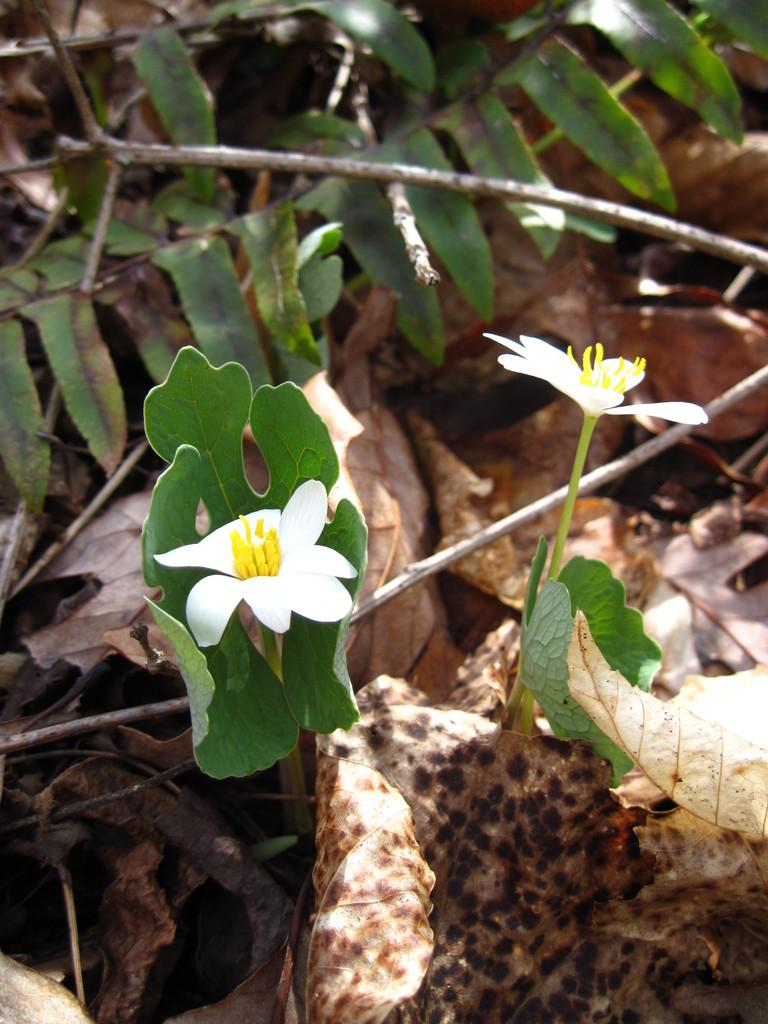What color are the leaves in the image? The leaves in the image are green. How many white color flowers are present in the image? There are two white color flowers in the image. What is the condition of some of the leaves in the image? There are dried leaves in the image. Where is the girl in the image? There is no girl present in the image; it features green leaves and white flowers. What type of land can be seen in the image? The image does not depict any land; it focuses on the leaves and flowers. 